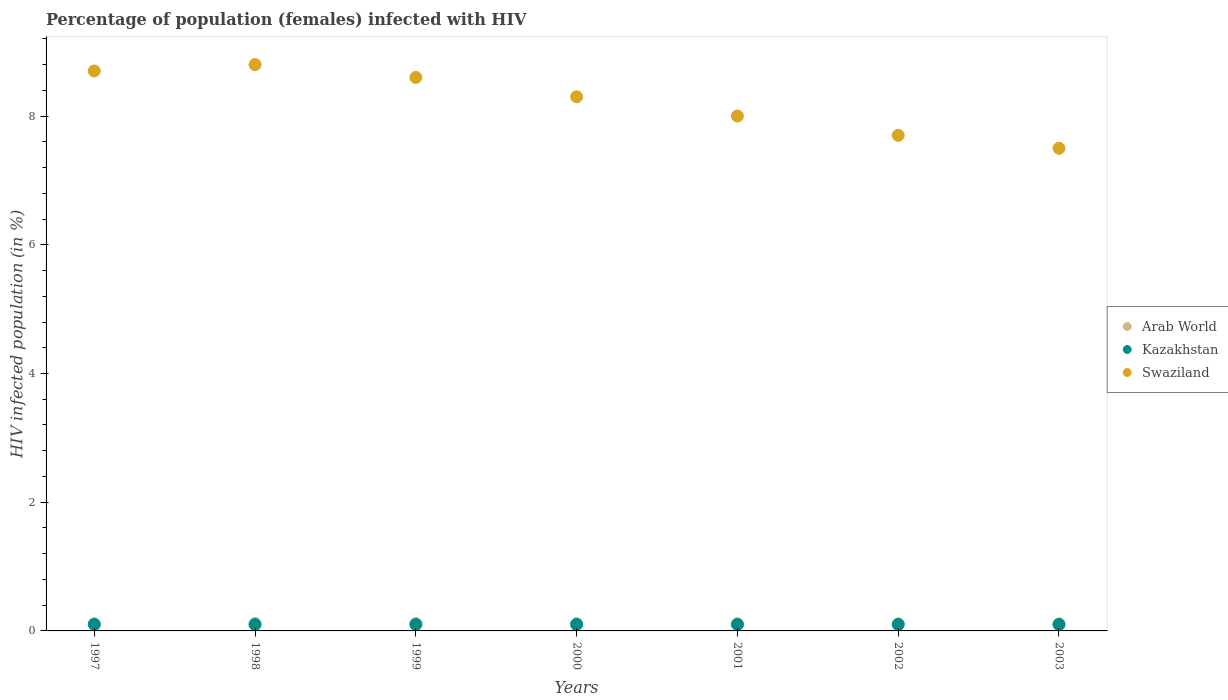What is the percentage of HIV infected female population in Arab World in 1997?
Your answer should be very brief. 0.11. Across all years, what is the maximum percentage of HIV infected female population in Arab World?
Provide a succinct answer. 0.11. Across all years, what is the minimum percentage of HIV infected female population in Kazakhstan?
Make the answer very short. 0.1. What is the total percentage of HIV infected female population in Swaziland in the graph?
Ensure brevity in your answer.  57.6. What is the difference between the percentage of HIV infected female population in Arab World in 1997 and that in 2000?
Offer a terse response. -0. What is the difference between the percentage of HIV infected female population in Arab World in 2003 and the percentage of HIV infected female population in Swaziland in 1999?
Offer a terse response. -8.49. What is the average percentage of HIV infected female population in Swaziland per year?
Make the answer very short. 8.23. In the year 1997, what is the difference between the percentage of HIV infected female population in Swaziland and percentage of HIV infected female population in Arab World?
Your answer should be compact. 8.59. What is the ratio of the percentage of HIV infected female population in Arab World in 1997 to that in 2003?
Provide a succinct answer. 1.03. What is the difference between the highest and the second highest percentage of HIV infected female population in Swaziland?
Your response must be concise. 0.1. What is the difference between the highest and the lowest percentage of HIV infected female population in Kazakhstan?
Your answer should be compact. 0. Is the percentage of HIV infected female population in Swaziland strictly less than the percentage of HIV infected female population in Arab World over the years?
Give a very brief answer. No. How many dotlines are there?
Offer a terse response. 3. How many years are there in the graph?
Your answer should be compact. 7. Are the values on the major ticks of Y-axis written in scientific E-notation?
Ensure brevity in your answer.  No. Does the graph contain grids?
Provide a short and direct response. No. Where does the legend appear in the graph?
Provide a short and direct response. Center right. How many legend labels are there?
Offer a terse response. 3. How are the legend labels stacked?
Offer a very short reply. Vertical. What is the title of the graph?
Your answer should be very brief. Percentage of population (females) infected with HIV. What is the label or title of the X-axis?
Ensure brevity in your answer.  Years. What is the label or title of the Y-axis?
Make the answer very short. HIV infected population (in %). What is the HIV infected population (in %) in Arab World in 1997?
Your response must be concise. 0.11. What is the HIV infected population (in %) in Swaziland in 1997?
Provide a short and direct response. 8.7. What is the HIV infected population (in %) of Arab World in 1998?
Your answer should be very brief. 0.11. What is the HIV infected population (in %) of Kazakhstan in 1998?
Give a very brief answer. 0.1. What is the HIV infected population (in %) in Swaziland in 1998?
Ensure brevity in your answer.  8.8. What is the HIV infected population (in %) in Arab World in 1999?
Provide a succinct answer. 0.11. What is the HIV infected population (in %) in Swaziland in 1999?
Provide a short and direct response. 8.6. What is the HIV infected population (in %) in Arab World in 2000?
Make the answer very short. 0.11. What is the HIV infected population (in %) of Swaziland in 2000?
Ensure brevity in your answer.  8.3. What is the HIV infected population (in %) in Arab World in 2001?
Offer a terse response. 0.11. What is the HIV infected population (in %) in Kazakhstan in 2001?
Your answer should be compact. 0.1. What is the HIV infected population (in %) in Swaziland in 2001?
Make the answer very short. 8. What is the HIV infected population (in %) in Arab World in 2002?
Your answer should be compact. 0.11. What is the HIV infected population (in %) of Kazakhstan in 2002?
Your answer should be very brief. 0.1. What is the HIV infected population (in %) in Arab World in 2003?
Offer a very short reply. 0.11. What is the HIV infected population (in %) in Kazakhstan in 2003?
Give a very brief answer. 0.1. What is the HIV infected population (in %) in Swaziland in 2003?
Provide a short and direct response. 7.5. Across all years, what is the maximum HIV infected population (in %) of Arab World?
Make the answer very short. 0.11. Across all years, what is the maximum HIV infected population (in %) of Kazakhstan?
Ensure brevity in your answer.  0.1. Across all years, what is the maximum HIV infected population (in %) of Swaziland?
Your answer should be very brief. 8.8. Across all years, what is the minimum HIV infected population (in %) of Arab World?
Provide a short and direct response. 0.11. Across all years, what is the minimum HIV infected population (in %) in Kazakhstan?
Provide a succinct answer. 0.1. Across all years, what is the minimum HIV infected population (in %) of Swaziland?
Provide a succinct answer. 7.5. What is the total HIV infected population (in %) in Arab World in the graph?
Your answer should be compact. 0.78. What is the total HIV infected population (in %) in Kazakhstan in the graph?
Your answer should be very brief. 0.7. What is the total HIV infected population (in %) in Swaziland in the graph?
Make the answer very short. 57.6. What is the difference between the HIV infected population (in %) in Arab World in 1997 and that in 1998?
Make the answer very short. -0. What is the difference between the HIV infected population (in %) of Kazakhstan in 1997 and that in 1998?
Ensure brevity in your answer.  0. What is the difference between the HIV infected population (in %) of Arab World in 1997 and that in 1999?
Ensure brevity in your answer.  -0. What is the difference between the HIV infected population (in %) in Kazakhstan in 1997 and that in 1999?
Provide a succinct answer. 0. What is the difference between the HIV infected population (in %) of Arab World in 1997 and that in 2000?
Provide a short and direct response. -0. What is the difference between the HIV infected population (in %) in Kazakhstan in 1997 and that in 2000?
Your answer should be compact. 0. What is the difference between the HIV infected population (in %) in Swaziland in 1997 and that in 2000?
Give a very brief answer. 0.4. What is the difference between the HIV infected population (in %) in Arab World in 1997 and that in 2001?
Keep it short and to the point. 0. What is the difference between the HIV infected population (in %) of Kazakhstan in 1997 and that in 2001?
Your response must be concise. 0. What is the difference between the HIV infected population (in %) of Swaziland in 1997 and that in 2001?
Keep it short and to the point. 0.7. What is the difference between the HIV infected population (in %) of Arab World in 1997 and that in 2002?
Ensure brevity in your answer.  0. What is the difference between the HIV infected population (in %) in Kazakhstan in 1997 and that in 2002?
Keep it short and to the point. 0. What is the difference between the HIV infected population (in %) of Swaziland in 1997 and that in 2002?
Provide a succinct answer. 1. What is the difference between the HIV infected population (in %) in Arab World in 1997 and that in 2003?
Provide a succinct answer. 0. What is the difference between the HIV infected population (in %) in Kazakhstan in 1997 and that in 2003?
Keep it short and to the point. 0. What is the difference between the HIV infected population (in %) of Swaziland in 1997 and that in 2003?
Your answer should be compact. 1.2. What is the difference between the HIV infected population (in %) of Kazakhstan in 1998 and that in 1999?
Keep it short and to the point. 0. What is the difference between the HIV infected population (in %) of Swaziland in 1998 and that in 1999?
Your answer should be compact. 0.2. What is the difference between the HIV infected population (in %) of Arab World in 1998 and that in 2000?
Your response must be concise. 0. What is the difference between the HIV infected population (in %) of Swaziland in 1998 and that in 2000?
Your answer should be very brief. 0.5. What is the difference between the HIV infected population (in %) of Arab World in 1998 and that in 2001?
Offer a terse response. 0. What is the difference between the HIV infected population (in %) of Kazakhstan in 1998 and that in 2001?
Make the answer very short. 0. What is the difference between the HIV infected population (in %) in Swaziland in 1998 and that in 2001?
Your answer should be very brief. 0.8. What is the difference between the HIV infected population (in %) in Arab World in 1998 and that in 2002?
Ensure brevity in your answer.  0. What is the difference between the HIV infected population (in %) of Swaziland in 1998 and that in 2002?
Your response must be concise. 1.1. What is the difference between the HIV infected population (in %) of Arab World in 1998 and that in 2003?
Keep it short and to the point. 0. What is the difference between the HIV infected population (in %) of Kazakhstan in 1998 and that in 2003?
Your response must be concise. 0. What is the difference between the HIV infected population (in %) in Swaziland in 1998 and that in 2003?
Ensure brevity in your answer.  1.3. What is the difference between the HIV infected population (in %) in Arab World in 1999 and that in 2000?
Your answer should be very brief. 0. What is the difference between the HIV infected population (in %) in Arab World in 1999 and that in 2001?
Offer a terse response. 0. What is the difference between the HIV infected population (in %) in Swaziland in 1999 and that in 2001?
Offer a terse response. 0.6. What is the difference between the HIV infected population (in %) in Arab World in 1999 and that in 2002?
Your response must be concise. 0. What is the difference between the HIV infected population (in %) in Arab World in 1999 and that in 2003?
Ensure brevity in your answer.  0. What is the difference between the HIV infected population (in %) of Swaziland in 1999 and that in 2003?
Offer a terse response. 1.1. What is the difference between the HIV infected population (in %) in Arab World in 2000 and that in 2001?
Your answer should be compact. 0. What is the difference between the HIV infected population (in %) in Arab World in 2000 and that in 2002?
Ensure brevity in your answer.  0. What is the difference between the HIV infected population (in %) of Arab World in 2000 and that in 2003?
Give a very brief answer. 0. What is the difference between the HIV infected population (in %) of Kazakhstan in 2000 and that in 2003?
Offer a very short reply. 0. What is the difference between the HIV infected population (in %) of Arab World in 2001 and that in 2002?
Offer a terse response. 0. What is the difference between the HIV infected population (in %) in Arab World in 2001 and that in 2003?
Give a very brief answer. 0. What is the difference between the HIV infected population (in %) in Kazakhstan in 2001 and that in 2003?
Your response must be concise. 0. What is the difference between the HIV infected population (in %) in Swaziland in 2001 and that in 2003?
Your response must be concise. 0.5. What is the difference between the HIV infected population (in %) in Arab World in 2002 and that in 2003?
Your answer should be compact. 0. What is the difference between the HIV infected population (in %) in Kazakhstan in 2002 and that in 2003?
Your response must be concise. 0. What is the difference between the HIV infected population (in %) of Swaziland in 2002 and that in 2003?
Offer a very short reply. 0.2. What is the difference between the HIV infected population (in %) of Arab World in 1997 and the HIV infected population (in %) of Kazakhstan in 1998?
Make the answer very short. 0.01. What is the difference between the HIV infected population (in %) in Arab World in 1997 and the HIV infected population (in %) in Swaziland in 1998?
Keep it short and to the point. -8.69. What is the difference between the HIV infected population (in %) of Arab World in 1997 and the HIV infected population (in %) of Kazakhstan in 1999?
Your response must be concise. 0.01. What is the difference between the HIV infected population (in %) of Arab World in 1997 and the HIV infected population (in %) of Swaziland in 1999?
Your answer should be very brief. -8.49. What is the difference between the HIV infected population (in %) in Arab World in 1997 and the HIV infected population (in %) in Kazakhstan in 2000?
Provide a short and direct response. 0.01. What is the difference between the HIV infected population (in %) of Arab World in 1997 and the HIV infected population (in %) of Swaziland in 2000?
Offer a terse response. -8.19. What is the difference between the HIV infected population (in %) in Arab World in 1997 and the HIV infected population (in %) in Kazakhstan in 2001?
Ensure brevity in your answer.  0.01. What is the difference between the HIV infected population (in %) of Arab World in 1997 and the HIV infected population (in %) of Swaziland in 2001?
Provide a succinct answer. -7.89. What is the difference between the HIV infected population (in %) in Arab World in 1997 and the HIV infected population (in %) in Kazakhstan in 2002?
Your answer should be very brief. 0.01. What is the difference between the HIV infected population (in %) of Arab World in 1997 and the HIV infected population (in %) of Swaziland in 2002?
Provide a short and direct response. -7.59. What is the difference between the HIV infected population (in %) in Kazakhstan in 1997 and the HIV infected population (in %) in Swaziland in 2002?
Give a very brief answer. -7.6. What is the difference between the HIV infected population (in %) of Arab World in 1997 and the HIV infected population (in %) of Kazakhstan in 2003?
Your answer should be compact. 0.01. What is the difference between the HIV infected population (in %) of Arab World in 1997 and the HIV infected population (in %) of Swaziland in 2003?
Offer a terse response. -7.39. What is the difference between the HIV infected population (in %) of Arab World in 1998 and the HIV infected population (in %) of Kazakhstan in 1999?
Your answer should be compact. 0.01. What is the difference between the HIV infected population (in %) in Arab World in 1998 and the HIV infected population (in %) in Swaziland in 1999?
Offer a terse response. -8.49. What is the difference between the HIV infected population (in %) in Kazakhstan in 1998 and the HIV infected population (in %) in Swaziland in 1999?
Your answer should be very brief. -8.5. What is the difference between the HIV infected population (in %) in Arab World in 1998 and the HIV infected population (in %) in Kazakhstan in 2000?
Offer a terse response. 0.01. What is the difference between the HIV infected population (in %) of Arab World in 1998 and the HIV infected population (in %) of Swaziland in 2000?
Ensure brevity in your answer.  -8.19. What is the difference between the HIV infected population (in %) of Arab World in 1998 and the HIV infected population (in %) of Kazakhstan in 2001?
Make the answer very short. 0.01. What is the difference between the HIV infected population (in %) in Arab World in 1998 and the HIV infected population (in %) in Swaziland in 2001?
Your answer should be very brief. -7.89. What is the difference between the HIV infected population (in %) of Arab World in 1998 and the HIV infected population (in %) of Kazakhstan in 2002?
Give a very brief answer. 0.01. What is the difference between the HIV infected population (in %) of Arab World in 1998 and the HIV infected population (in %) of Swaziland in 2002?
Your answer should be compact. -7.59. What is the difference between the HIV infected population (in %) in Kazakhstan in 1998 and the HIV infected population (in %) in Swaziland in 2002?
Provide a succinct answer. -7.6. What is the difference between the HIV infected population (in %) in Arab World in 1998 and the HIV infected population (in %) in Kazakhstan in 2003?
Offer a terse response. 0.01. What is the difference between the HIV infected population (in %) of Arab World in 1998 and the HIV infected population (in %) of Swaziland in 2003?
Offer a terse response. -7.39. What is the difference between the HIV infected population (in %) in Kazakhstan in 1998 and the HIV infected population (in %) in Swaziland in 2003?
Your response must be concise. -7.4. What is the difference between the HIV infected population (in %) of Arab World in 1999 and the HIV infected population (in %) of Kazakhstan in 2000?
Offer a very short reply. 0.01. What is the difference between the HIV infected population (in %) of Arab World in 1999 and the HIV infected population (in %) of Swaziland in 2000?
Keep it short and to the point. -8.19. What is the difference between the HIV infected population (in %) of Arab World in 1999 and the HIV infected population (in %) of Kazakhstan in 2001?
Provide a short and direct response. 0.01. What is the difference between the HIV infected population (in %) in Arab World in 1999 and the HIV infected population (in %) in Swaziland in 2001?
Offer a very short reply. -7.89. What is the difference between the HIV infected population (in %) of Arab World in 1999 and the HIV infected population (in %) of Kazakhstan in 2002?
Offer a terse response. 0.01. What is the difference between the HIV infected population (in %) of Arab World in 1999 and the HIV infected population (in %) of Swaziland in 2002?
Ensure brevity in your answer.  -7.59. What is the difference between the HIV infected population (in %) of Arab World in 1999 and the HIV infected population (in %) of Kazakhstan in 2003?
Provide a short and direct response. 0.01. What is the difference between the HIV infected population (in %) in Arab World in 1999 and the HIV infected population (in %) in Swaziland in 2003?
Your answer should be compact. -7.39. What is the difference between the HIV infected population (in %) in Arab World in 2000 and the HIV infected population (in %) in Kazakhstan in 2001?
Keep it short and to the point. 0.01. What is the difference between the HIV infected population (in %) in Arab World in 2000 and the HIV infected population (in %) in Swaziland in 2001?
Keep it short and to the point. -7.89. What is the difference between the HIV infected population (in %) in Kazakhstan in 2000 and the HIV infected population (in %) in Swaziland in 2001?
Provide a short and direct response. -7.9. What is the difference between the HIV infected population (in %) in Arab World in 2000 and the HIV infected population (in %) in Kazakhstan in 2002?
Give a very brief answer. 0.01. What is the difference between the HIV infected population (in %) of Arab World in 2000 and the HIV infected population (in %) of Swaziland in 2002?
Your answer should be compact. -7.59. What is the difference between the HIV infected population (in %) in Kazakhstan in 2000 and the HIV infected population (in %) in Swaziland in 2002?
Offer a terse response. -7.6. What is the difference between the HIV infected population (in %) in Arab World in 2000 and the HIV infected population (in %) in Kazakhstan in 2003?
Provide a succinct answer. 0.01. What is the difference between the HIV infected population (in %) in Arab World in 2000 and the HIV infected population (in %) in Swaziland in 2003?
Your answer should be very brief. -7.39. What is the difference between the HIV infected population (in %) in Kazakhstan in 2000 and the HIV infected population (in %) in Swaziland in 2003?
Your answer should be very brief. -7.4. What is the difference between the HIV infected population (in %) in Arab World in 2001 and the HIV infected population (in %) in Kazakhstan in 2002?
Ensure brevity in your answer.  0.01. What is the difference between the HIV infected population (in %) of Arab World in 2001 and the HIV infected population (in %) of Swaziland in 2002?
Provide a succinct answer. -7.59. What is the difference between the HIV infected population (in %) of Arab World in 2001 and the HIV infected population (in %) of Swaziland in 2003?
Your answer should be compact. -7.39. What is the difference between the HIV infected population (in %) of Arab World in 2002 and the HIV infected population (in %) of Kazakhstan in 2003?
Keep it short and to the point. 0.01. What is the difference between the HIV infected population (in %) in Arab World in 2002 and the HIV infected population (in %) in Swaziland in 2003?
Make the answer very short. -7.39. What is the difference between the HIV infected population (in %) in Kazakhstan in 2002 and the HIV infected population (in %) in Swaziland in 2003?
Keep it short and to the point. -7.4. What is the average HIV infected population (in %) in Arab World per year?
Offer a terse response. 0.11. What is the average HIV infected population (in %) of Kazakhstan per year?
Provide a succinct answer. 0.1. What is the average HIV infected population (in %) in Swaziland per year?
Offer a very short reply. 8.23. In the year 1997, what is the difference between the HIV infected population (in %) in Arab World and HIV infected population (in %) in Kazakhstan?
Offer a very short reply. 0.01. In the year 1997, what is the difference between the HIV infected population (in %) in Arab World and HIV infected population (in %) in Swaziland?
Offer a terse response. -8.59. In the year 1998, what is the difference between the HIV infected population (in %) in Arab World and HIV infected population (in %) in Kazakhstan?
Provide a succinct answer. 0.01. In the year 1998, what is the difference between the HIV infected population (in %) in Arab World and HIV infected population (in %) in Swaziland?
Give a very brief answer. -8.69. In the year 1998, what is the difference between the HIV infected population (in %) of Kazakhstan and HIV infected population (in %) of Swaziland?
Offer a terse response. -8.7. In the year 1999, what is the difference between the HIV infected population (in %) in Arab World and HIV infected population (in %) in Kazakhstan?
Your response must be concise. 0.01. In the year 1999, what is the difference between the HIV infected population (in %) in Arab World and HIV infected population (in %) in Swaziland?
Ensure brevity in your answer.  -8.49. In the year 1999, what is the difference between the HIV infected population (in %) in Kazakhstan and HIV infected population (in %) in Swaziland?
Keep it short and to the point. -8.5. In the year 2000, what is the difference between the HIV infected population (in %) in Arab World and HIV infected population (in %) in Kazakhstan?
Offer a very short reply. 0.01. In the year 2000, what is the difference between the HIV infected population (in %) of Arab World and HIV infected population (in %) of Swaziland?
Make the answer very short. -8.19. In the year 2001, what is the difference between the HIV infected population (in %) of Arab World and HIV infected population (in %) of Kazakhstan?
Make the answer very short. 0.01. In the year 2001, what is the difference between the HIV infected population (in %) in Arab World and HIV infected population (in %) in Swaziland?
Provide a succinct answer. -7.89. In the year 2002, what is the difference between the HIV infected population (in %) in Arab World and HIV infected population (in %) in Kazakhstan?
Keep it short and to the point. 0.01. In the year 2002, what is the difference between the HIV infected population (in %) of Arab World and HIV infected population (in %) of Swaziland?
Offer a terse response. -7.59. In the year 2002, what is the difference between the HIV infected population (in %) in Kazakhstan and HIV infected population (in %) in Swaziland?
Your response must be concise. -7.6. In the year 2003, what is the difference between the HIV infected population (in %) in Arab World and HIV infected population (in %) in Kazakhstan?
Offer a very short reply. 0.01. In the year 2003, what is the difference between the HIV infected population (in %) of Arab World and HIV infected population (in %) of Swaziland?
Your answer should be compact. -7.39. In the year 2003, what is the difference between the HIV infected population (in %) of Kazakhstan and HIV infected population (in %) of Swaziland?
Ensure brevity in your answer.  -7.4. What is the ratio of the HIV infected population (in %) in Arab World in 1997 to that in 1998?
Your answer should be very brief. 0.99. What is the ratio of the HIV infected population (in %) of Kazakhstan in 1997 to that in 1998?
Ensure brevity in your answer.  1. What is the ratio of the HIV infected population (in %) in Arab World in 1997 to that in 1999?
Offer a terse response. 0.99. What is the ratio of the HIV infected population (in %) of Swaziland in 1997 to that in 1999?
Your response must be concise. 1.01. What is the ratio of the HIV infected population (in %) in Swaziland in 1997 to that in 2000?
Ensure brevity in your answer.  1.05. What is the ratio of the HIV infected population (in %) in Arab World in 1997 to that in 2001?
Your response must be concise. 1.02. What is the ratio of the HIV infected population (in %) in Swaziland in 1997 to that in 2001?
Offer a very short reply. 1.09. What is the ratio of the HIV infected population (in %) of Arab World in 1997 to that in 2002?
Your answer should be compact. 1.02. What is the ratio of the HIV infected population (in %) in Swaziland in 1997 to that in 2002?
Offer a terse response. 1.13. What is the ratio of the HIV infected population (in %) in Arab World in 1997 to that in 2003?
Offer a terse response. 1.03. What is the ratio of the HIV infected population (in %) of Kazakhstan in 1997 to that in 2003?
Make the answer very short. 1. What is the ratio of the HIV infected population (in %) in Swaziland in 1997 to that in 2003?
Your answer should be very brief. 1.16. What is the ratio of the HIV infected population (in %) in Arab World in 1998 to that in 1999?
Provide a short and direct response. 1. What is the ratio of the HIV infected population (in %) of Swaziland in 1998 to that in 1999?
Your response must be concise. 1.02. What is the ratio of the HIV infected population (in %) in Arab World in 1998 to that in 2000?
Offer a terse response. 1.01. What is the ratio of the HIV infected population (in %) of Kazakhstan in 1998 to that in 2000?
Keep it short and to the point. 1. What is the ratio of the HIV infected population (in %) of Swaziland in 1998 to that in 2000?
Your answer should be compact. 1.06. What is the ratio of the HIV infected population (in %) of Arab World in 1998 to that in 2001?
Provide a succinct answer. 1.04. What is the ratio of the HIV infected population (in %) in Kazakhstan in 1998 to that in 2001?
Make the answer very short. 1. What is the ratio of the HIV infected population (in %) of Swaziland in 1998 to that in 2001?
Keep it short and to the point. 1.1. What is the ratio of the HIV infected population (in %) of Arab World in 1998 to that in 2002?
Ensure brevity in your answer.  1.04. What is the ratio of the HIV infected population (in %) in Kazakhstan in 1998 to that in 2002?
Offer a very short reply. 1. What is the ratio of the HIV infected population (in %) of Arab World in 1998 to that in 2003?
Make the answer very short. 1.04. What is the ratio of the HIV infected population (in %) in Kazakhstan in 1998 to that in 2003?
Offer a very short reply. 1. What is the ratio of the HIV infected population (in %) of Swaziland in 1998 to that in 2003?
Provide a short and direct response. 1.17. What is the ratio of the HIV infected population (in %) of Swaziland in 1999 to that in 2000?
Offer a terse response. 1.04. What is the ratio of the HIV infected population (in %) in Arab World in 1999 to that in 2001?
Ensure brevity in your answer.  1.03. What is the ratio of the HIV infected population (in %) of Kazakhstan in 1999 to that in 2001?
Your response must be concise. 1. What is the ratio of the HIV infected population (in %) in Swaziland in 1999 to that in 2001?
Provide a short and direct response. 1.07. What is the ratio of the HIV infected population (in %) in Arab World in 1999 to that in 2002?
Your answer should be compact. 1.03. What is the ratio of the HIV infected population (in %) in Kazakhstan in 1999 to that in 2002?
Your answer should be compact. 1. What is the ratio of the HIV infected population (in %) in Swaziland in 1999 to that in 2002?
Keep it short and to the point. 1.12. What is the ratio of the HIV infected population (in %) in Arab World in 1999 to that in 2003?
Keep it short and to the point. 1.04. What is the ratio of the HIV infected population (in %) of Swaziland in 1999 to that in 2003?
Your answer should be compact. 1.15. What is the ratio of the HIV infected population (in %) in Arab World in 2000 to that in 2001?
Keep it short and to the point. 1.03. What is the ratio of the HIV infected population (in %) of Kazakhstan in 2000 to that in 2001?
Ensure brevity in your answer.  1. What is the ratio of the HIV infected population (in %) of Swaziland in 2000 to that in 2001?
Your answer should be compact. 1.04. What is the ratio of the HIV infected population (in %) in Arab World in 2000 to that in 2002?
Keep it short and to the point. 1.03. What is the ratio of the HIV infected population (in %) of Kazakhstan in 2000 to that in 2002?
Make the answer very short. 1. What is the ratio of the HIV infected population (in %) in Swaziland in 2000 to that in 2002?
Your answer should be compact. 1.08. What is the ratio of the HIV infected population (in %) in Arab World in 2000 to that in 2003?
Offer a very short reply. 1.03. What is the ratio of the HIV infected population (in %) of Kazakhstan in 2000 to that in 2003?
Ensure brevity in your answer.  1. What is the ratio of the HIV infected population (in %) of Swaziland in 2000 to that in 2003?
Your answer should be compact. 1.11. What is the ratio of the HIV infected population (in %) of Swaziland in 2001 to that in 2002?
Offer a very short reply. 1.04. What is the ratio of the HIV infected population (in %) of Kazakhstan in 2001 to that in 2003?
Offer a very short reply. 1. What is the ratio of the HIV infected population (in %) in Swaziland in 2001 to that in 2003?
Your answer should be compact. 1.07. What is the ratio of the HIV infected population (in %) in Swaziland in 2002 to that in 2003?
Provide a short and direct response. 1.03. What is the difference between the highest and the second highest HIV infected population (in %) in Kazakhstan?
Offer a very short reply. 0. What is the difference between the highest and the lowest HIV infected population (in %) of Arab World?
Provide a short and direct response. 0. What is the difference between the highest and the lowest HIV infected population (in %) of Kazakhstan?
Provide a short and direct response. 0. 